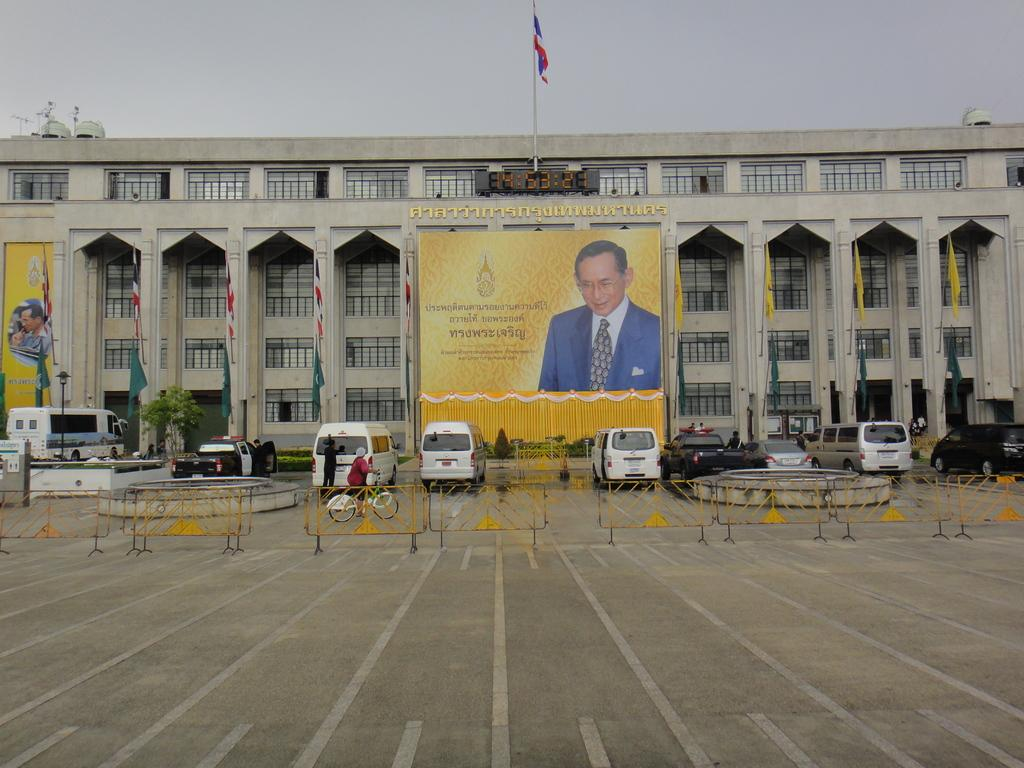What is the main structure in the image? There is a big building in the image. What is attached to a pole near the building? There is a flag on a pole near the building. What is displayed on the building? There is a banner on the building. What can be seen in front of the building? There are vehicles and a person riding a bicycle in front of the building. What is used to enclose the area in front of the building? There is a fence in front of the building. Where is the receipt for the oven located in the image? There is no receipt or oven present in the image. 